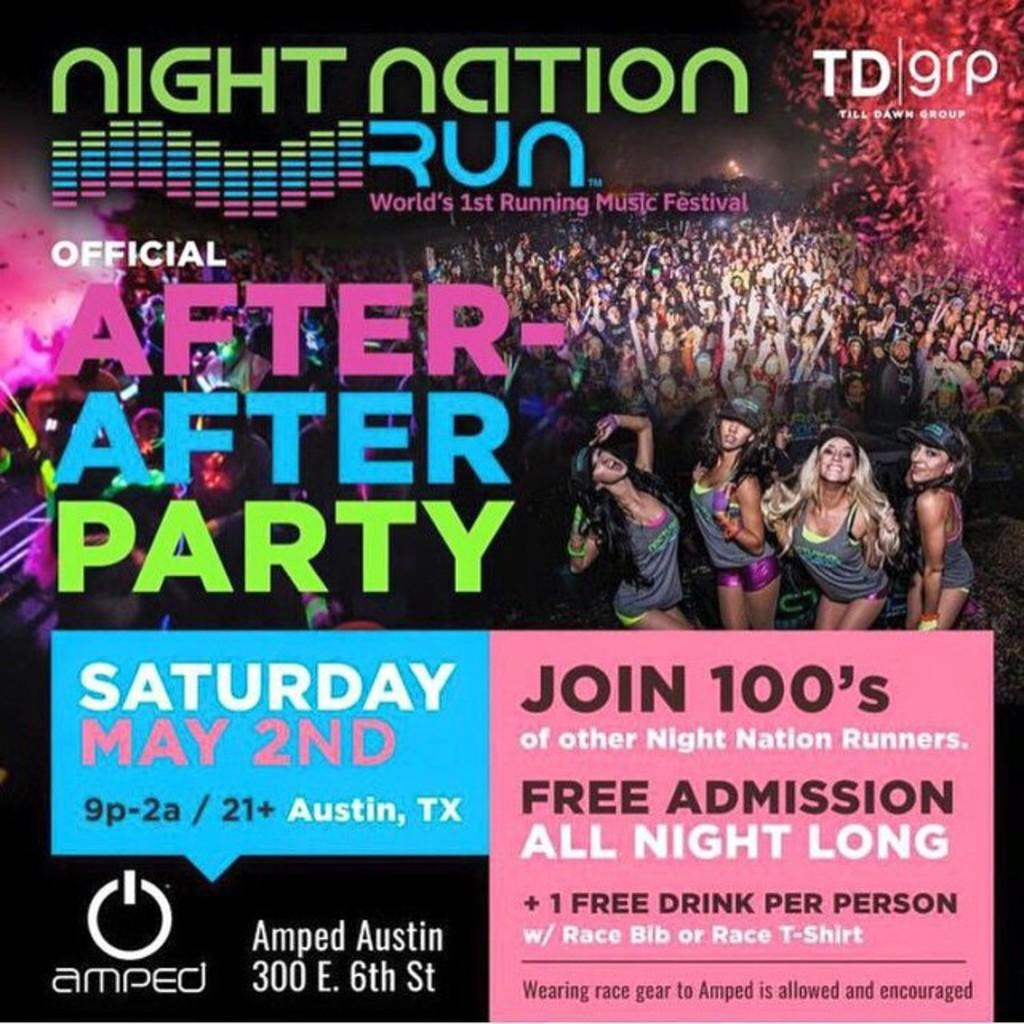What is present on the poster in the image? There is a poster in the image that contains words, numbers, a logo, and an image of a group of people standing. What type of information can be found on the poster? The poster contains both words and numbers. What is the purpose of the logo on the poster? The logo on the poster may represent a company, organization, or brand. Can you describe the image on the poster? The image on the poster shows a group of people standing. What color is the lip polish used by the people in the image? There are no people or lip polish present in the image; it only features a poster with various elements. 